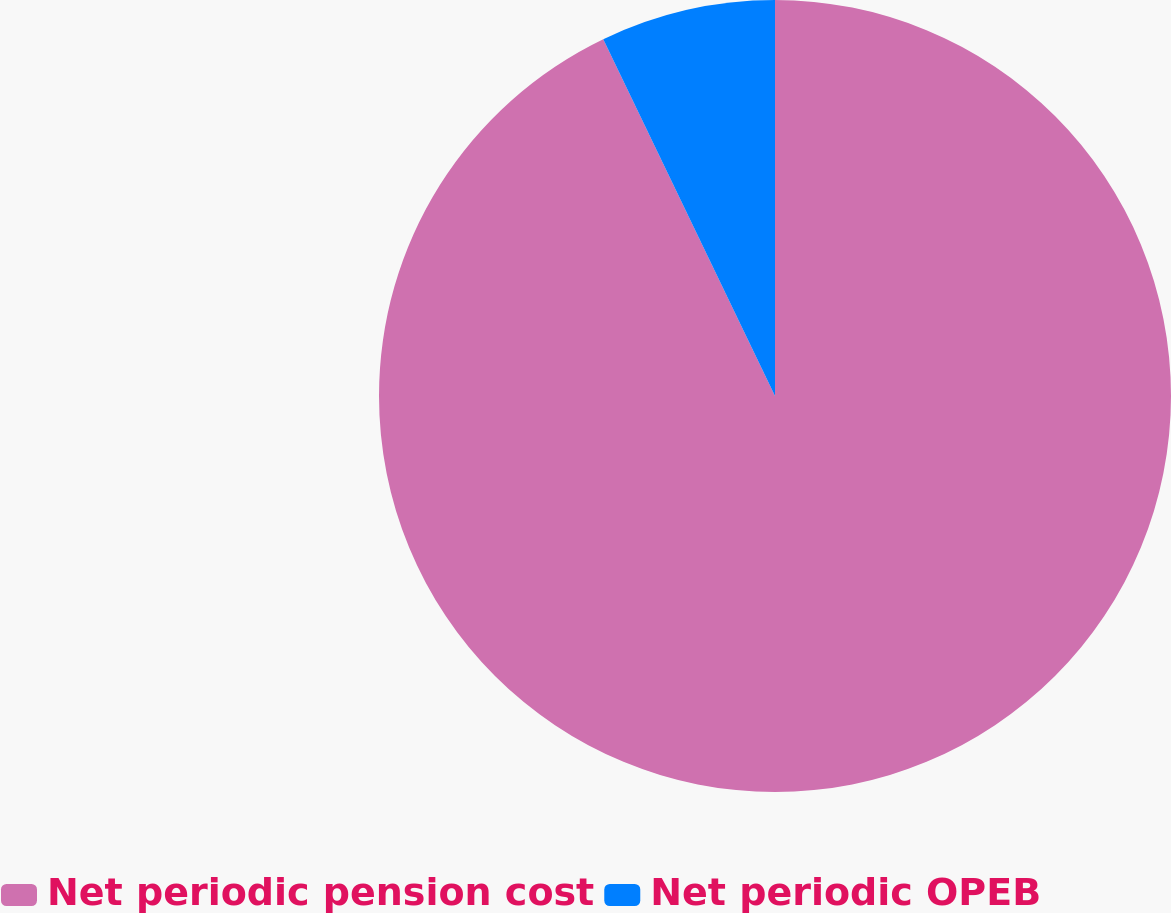Convert chart. <chart><loc_0><loc_0><loc_500><loc_500><pie_chart><fcel>Net periodic pension cost<fcel>Net periodic OPEB<nl><fcel>92.86%<fcel>7.14%<nl></chart> 